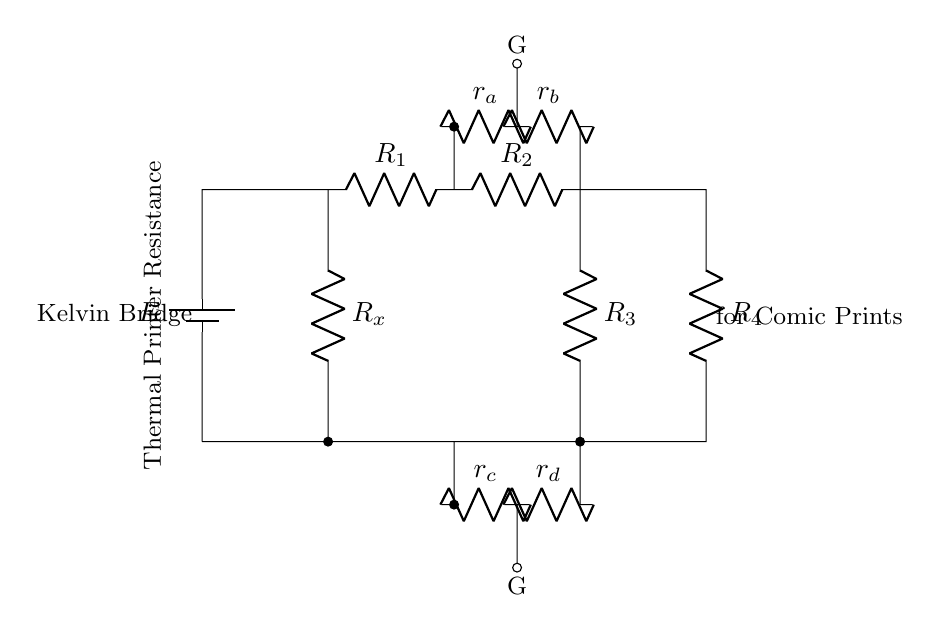What is the name of this circuit? The circuit is specifically labeled as a "Kelvin Bridge," which is used for precise resistance measurements.
Answer: Kelvin Bridge What are the resistors labeled in the circuit? The circuit has five resistors labeled as R1, R2, R3, R4, and Rx. R1 and R2 are in the upper arm, R3 is in the lower arm, and Rx represents the unknown resistance to be measured.
Answer: R1, R2, R3, R4, Rx How many resistors are in the bridge part of the circuit? The bridge part contains four resistors labeled as R1, R2, R3, and R4 which form the main components of the bridge configuration.
Answer: Four What does the symbol G represent in the circuit? The symbol G indicates the connection points for the galvanometer, which measures the current through the bridge and helps determine the balance.
Answer: Galvanometer What is the purpose of the resistors r_a, r_b, r_c, and r_d? Resistors r_a and r_b are likely for balance adjustments in the upper arm of the bridge, while r_c and r_d serve the same purpose in the lower arm, allowing fine-tuning of the bridge circuit for precise measurements.
Answer: Balance adjustments What type of printer is associated with this circuit? The labeled description indicates that this circuit is associated with a "Thermal Printer," specifically for use in producing limited edition comic prints.
Answer: Thermal Printer What is the significance of precise resistance measurement in this context? Precise resistance measurement is crucial in ensuring the thermal printer produces high-quality prints, as resistance affects the heating elements that control ink application.
Answer: Quality of prints 